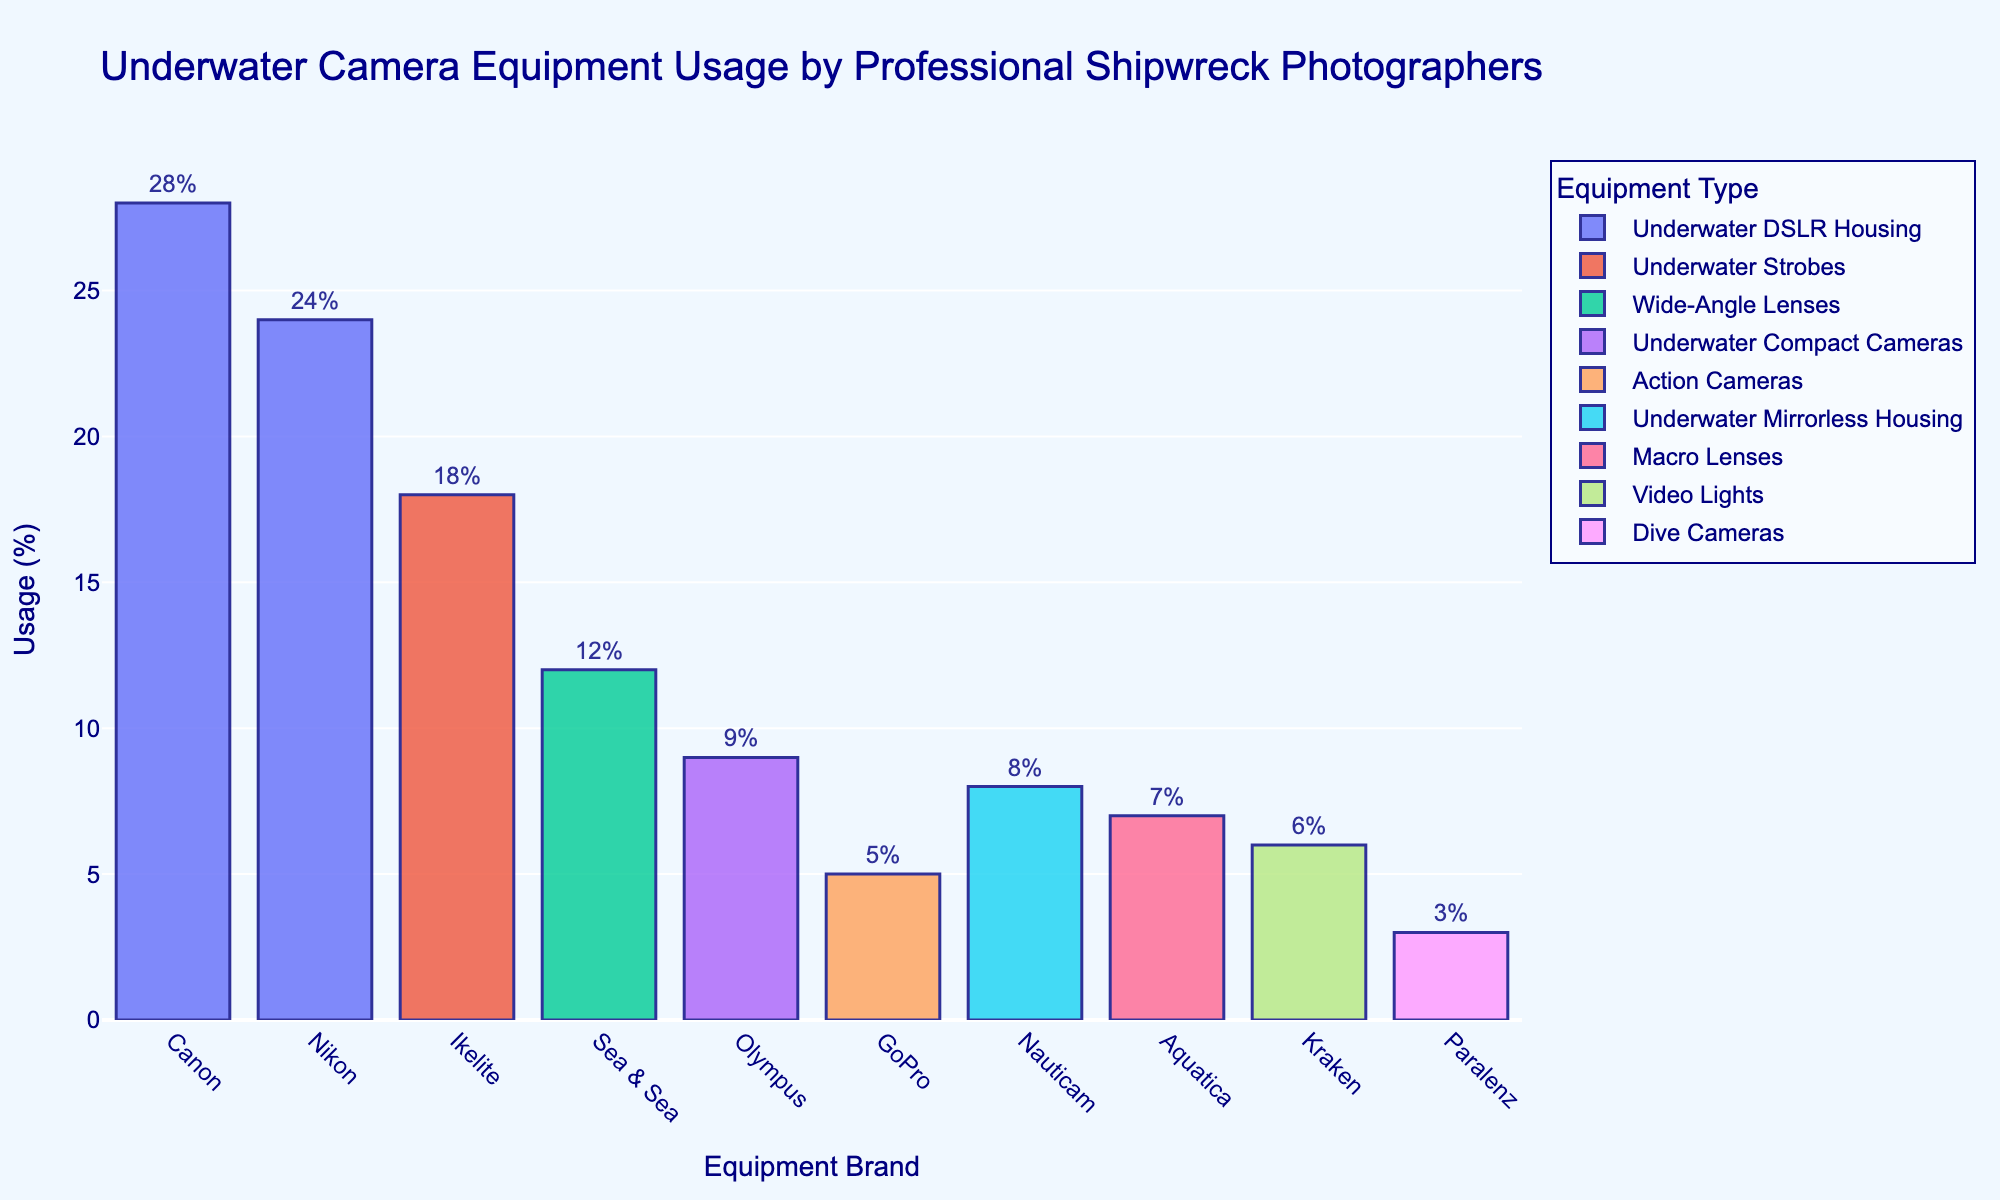Which brand has the highest usage percentage for underwater DSLR housing? By looking at the bars labeled "Underwater DSLR Housing" and comparing their heights, we see that Canon has a higher bar than Nikon. Thus, Canon has the highest usage percentage for underwater DSLR housing.
Answer: Canon Which equipment type has the smallest usage percentage? By observing the heights of the bars and their corresponding equipment types, we see that the bar labeled "Dive Cameras" is the shortest. Thus, the dive cameras have the smallest usage percentage.
Answer: Dive Cameras How much more usage percentage does Ikelite's equipment have compared to Paralenz's? Ikelite's usage percentage is 18% and Paralenz's is 3%. Subtract Paralenz's percentage from Ikelite's: 18 - 3 = 15. Therefore, Ikelite's equipment has 15% more usage.
Answer: 15% What is the combined usage percentage of wide-angle lenses and macro lenses? Wide-angle lenses (Sea & Sea) have a usage percentage of 12% and macro lenses (Aquatica) have 7%. Summing these gives 12 + 7 = 19%. Thus, the combined usage is 19%.
Answer: 19% Which brands have a usage percentage greater than 10%? By comparing the heights of the bars, the brands with a usage percentage greater than 10% are Canon, Nikon, and Ikelite.
Answer: Canon, Nikon, Ikelite What is the average usage percentage of the equipment types used by Canon, Nikon, and Olympus? Canon's usage is 28%, Nikon's is 24%, and Olympus's is 9%. The average is calculated by summing these percentages and dividing by the number of brands: (28 + 24 + 9) / 3 = 20.33%. Thus, the average usage percentage is 20.33%.
Answer: 20.33% By how much does the usage percentage of action cameras differ from that of underwater mirrorless housing? The usage percentage of action cameras (GoPro) is 5%, while underwater mirrorless housing (Nauticam) is 8%. The difference is 8 - 5 = 3%. Thus, the usage percentage differs by 3%.
Answer: 3% Is the usage percentage of video lights greater than or less than the usage percentage of dive cameras? By looking at the heights of the bars and comparing "Video Lights" (Kraken) and "Dive Cameras" (Paralenz), we see that video lights have a higher bar. Thus, the usage percentage of video lights is greater than that of dive cameras.
Answer: Greater Which equipment type used by Sea & Sea has what usage percentage? The bar corresponding to Sea & Sea is labeled "Wide-Angle Lenses," and it has a usage percentage of 12%.
Answer: Wide-Angle Lenses, 12% What is the total usage percentage of the three least used equipment types? The three least used equipment types are Dive Cameras (3%), GoPro Action Cameras (5%), and Kraken Video Lights (6%). Summing these gives 3 + 5 + 6 = 14%. Thus, the total usage percentage is 14%.
Answer: 14% 